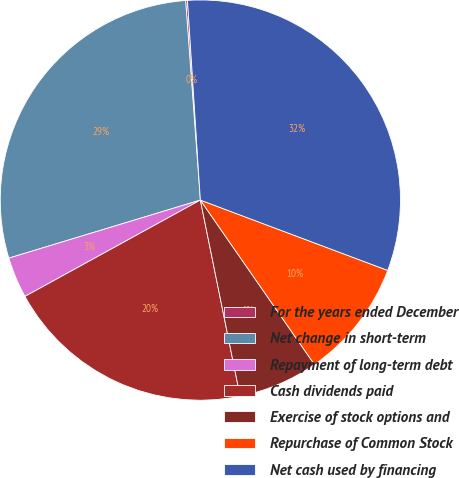Convert chart to OTSL. <chart><loc_0><loc_0><loc_500><loc_500><pie_chart><fcel>For the years ended December<fcel>Net change in short-term<fcel>Repayment of long-term debt<fcel>Cash dividends paid<fcel>Exercise of stock options and<fcel>Repurchase of Common Stock<fcel>Net cash used by financing<nl><fcel>0.15%<fcel>28.51%<fcel>3.31%<fcel>20.19%<fcel>6.47%<fcel>9.63%<fcel>31.74%<nl></chart> 